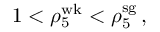Convert formula to latex. <formula><loc_0><loc_0><loc_500><loc_500>1 < \rho _ { 5 } ^ { w k } < \rho _ { 5 } ^ { s g } \, ,</formula> 